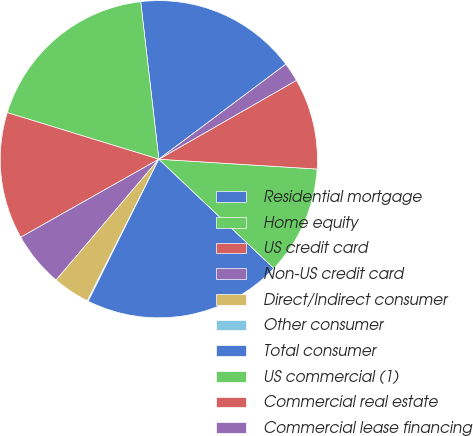<chart> <loc_0><loc_0><loc_500><loc_500><pie_chart><fcel>Residential mortgage<fcel>Home equity<fcel>US credit card<fcel>Non-US credit card<fcel>Direct/Indirect consumer<fcel>Other consumer<fcel>Total consumer<fcel>US commercial (1)<fcel>Commercial real estate<fcel>Commercial lease financing<nl><fcel>16.6%<fcel>18.43%<fcel>12.93%<fcel>5.6%<fcel>3.77%<fcel>0.1%<fcel>20.26%<fcel>11.1%<fcel>9.27%<fcel>1.94%<nl></chart> 